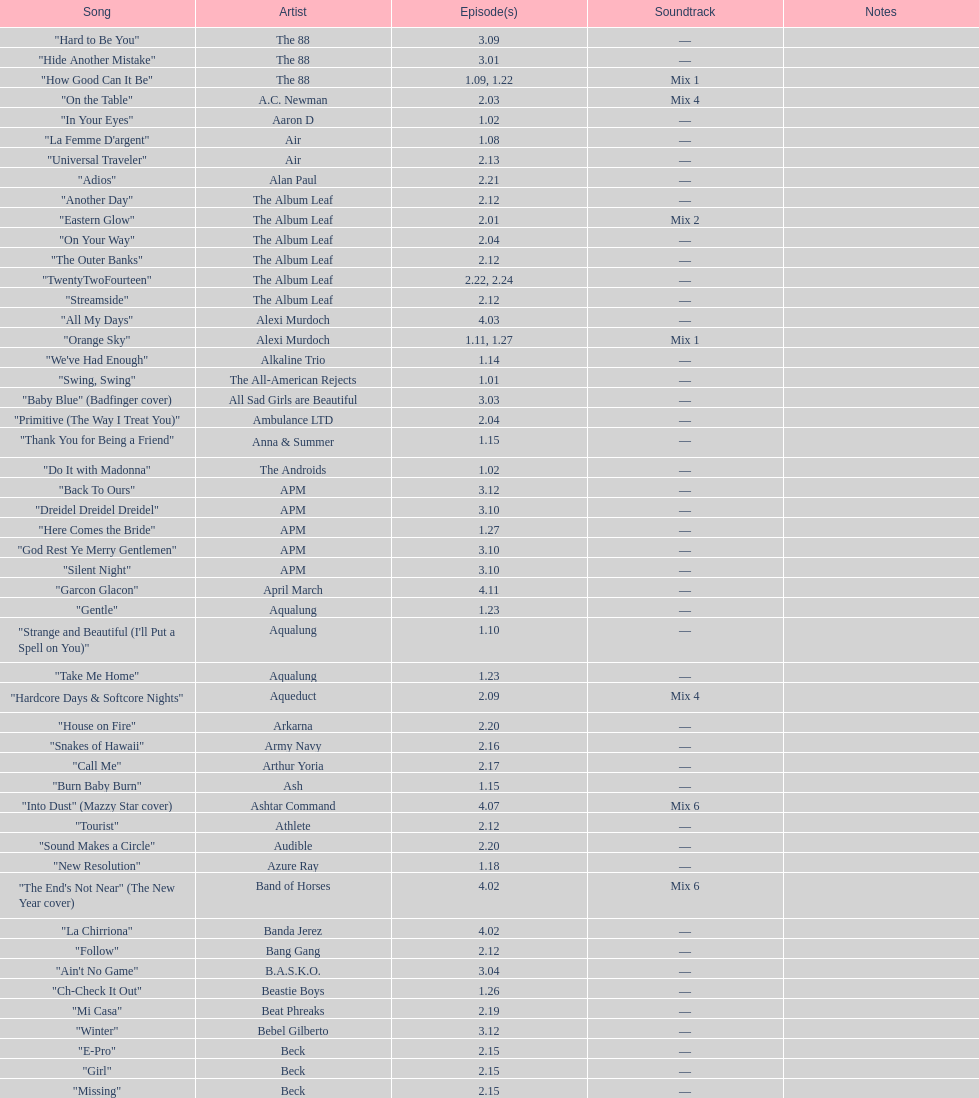What artist has more music appear in the show, daft punk or franz ferdinand? Franz Ferdinand. 